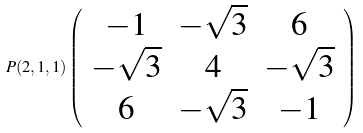<formula> <loc_0><loc_0><loc_500><loc_500>P ( 2 , 1 , 1 ) \left ( \begin{array} { c c c } - 1 & - \sqrt { 3 } & 6 \\ - \sqrt { 3 } & 4 & - \sqrt { 3 } \\ 6 & - \sqrt { 3 } & - 1 \end{array} \right )</formula> 